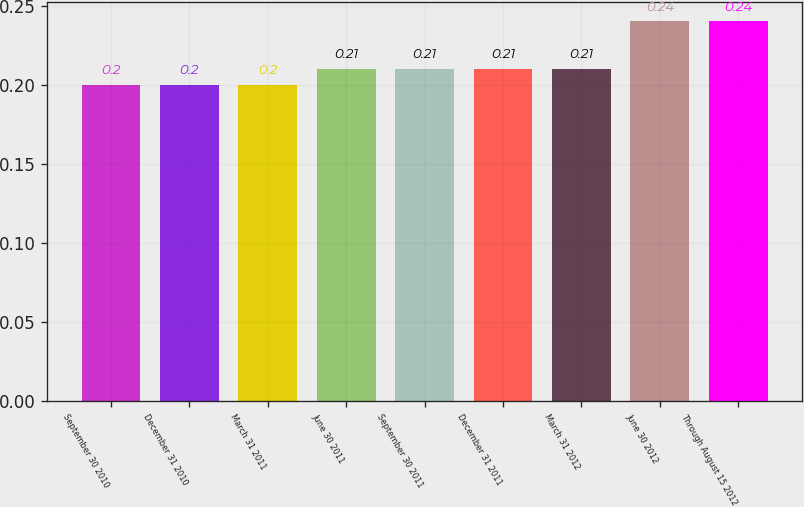<chart> <loc_0><loc_0><loc_500><loc_500><bar_chart><fcel>September 30 2010<fcel>December 31 2010<fcel>March 31 2011<fcel>June 30 2011<fcel>September 30 2011<fcel>December 31 2011<fcel>March 31 2012<fcel>June 30 2012<fcel>Through August 15 2012<nl><fcel>0.2<fcel>0.2<fcel>0.2<fcel>0.21<fcel>0.21<fcel>0.21<fcel>0.21<fcel>0.24<fcel>0.24<nl></chart> 